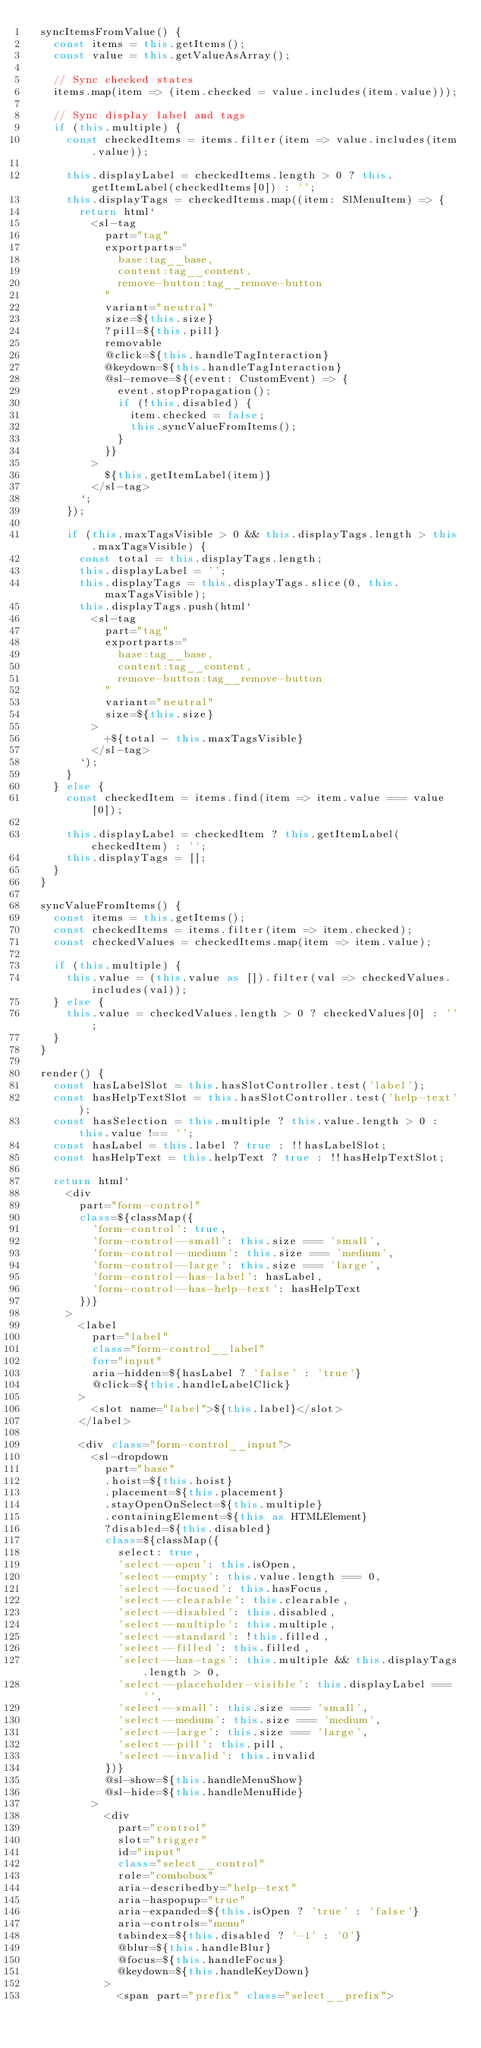<code> <loc_0><loc_0><loc_500><loc_500><_TypeScript_>  syncItemsFromValue() {
    const items = this.getItems();
    const value = this.getValueAsArray();

    // Sync checked states
    items.map(item => (item.checked = value.includes(item.value)));

    // Sync display label and tags
    if (this.multiple) {
      const checkedItems = items.filter(item => value.includes(item.value));

      this.displayLabel = checkedItems.length > 0 ? this.getItemLabel(checkedItems[0]) : '';
      this.displayTags = checkedItems.map((item: SlMenuItem) => {
        return html`
          <sl-tag
            part="tag"
            exportparts="
              base:tag__base,
              content:tag__content,
              remove-button:tag__remove-button
            "
            variant="neutral"
            size=${this.size}
            ?pill=${this.pill}
            removable
            @click=${this.handleTagInteraction}
            @keydown=${this.handleTagInteraction}
            @sl-remove=${(event: CustomEvent) => {
              event.stopPropagation();
              if (!this.disabled) {
                item.checked = false;
                this.syncValueFromItems();
              }
            }}
          >
            ${this.getItemLabel(item)}
          </sl-tag>
        `;
      });

      if (this.maxTagsVisible > 0 && this.displayTags.length > this.maxTagsVisible) {
        const total = this.displayTags.length;
        this.displayLabel = '';
        this.displayTags = this.displayTags.slice(0, this.maxTagsVisible);
        this.displayTags.push(html`
          <sl-tag
            part="tag"
            exportparts="
              base:tag__base,
              content:tag__content,
              remove-button:tag__remove-button
            "
            variant="neutral"
            size=${this.size}
          >
            +${total - this.maxTagsVisible}
          </sl-tag>
        `);
      }
    } else {
      const checkedItem = items.find(item => item.value === value[0]);

      this.displayLabel = checkedItem ? this.getItemLabel(checkedItem) : '';
      this.displayTags = [];
    }
  }

  syncValueFromItems() {
    const items = this.getItems();
    const checkedItems = items.filter(item => item.checked);
    const checkedValues = checkedItems.map(item => item.value);

    if (this.multiple) {
      this.value = (this.value as []).filter(val => checkedValues.includes(val));
    } else {
      this.value = checkedValues.length > 0 ? checkedValues[0] : '';
    }
  }

  render() {
    const hasLabelSlot = this.hasSlotController.test('label');
    const hasHelpTextSlot = this.hasSlotController.test('help-text');
    const hasSelection = this.multiple ? this.value.length > 0 : this.value !== '';
    const hasLabel = this.label ? true : !!hasLabelSlot;
    const hasHelpText = this.helpText ? true : !!hasHelpTextSlot;

    return html`
      <div
        part="form-control"
        class=${classMap({
          'form-control': true,
          'form-control--small': this.size === 'small',
          'form-control--medium': this.size === 'medium',
          'form-control--large': this.size === 'large',
          'form-control--has-label': hasLabel,
          'form-control--has-help-text': hasHelpText
        })}
      >
        <label
          part="label"
          class="form-control__label"
          for="input"
          aria-hidden=${hasLabel ? 'false' : 'true'}
          @click=${this.handleLabelClick}
        >
          <slot name="label">${this.label}</slot>
        </label>

        <div class="form-control__input">
          <sl-dropdown
            part="base"
            .hoist=${this.hoist}
            .placement=${this.placement}
            .stayOpenOnSelect=${this.multiple}
            .containingElement=${this as HTMLElement}
            ?disabled=${this.disabled}
            class=${classMap({
              select: true,
              'select--open': this.isOpen,
              'select--empty': this.value.length === 0,
              'select--focused': this.hasFocus,
              'select--clearable': this.clearable,
              'select--disabled': this.disabled,
              'select--multiple': this.multiple,
              'select--standard': !this.filled,
              'select--filled': this.filled,
              'select--has-tags': this.multiple && this.displayTags.length > 0,
              'select--placeholder-visible': this.displayLabel === '',
              'select--small': this.size === 'small',
              'select--medium': this.size === 'medium',
              'select--large': this.size === 'large',
              'select--pill': this.pill,
              'select--invalid': this.invalid
            })}
            @sl-show=${this.handleMenuShow}
            @sl-hide=${this.handleMenuHide}
          >
            <div
              part="control"
              slot="trigger"
              id="input"
              class="select__control"
              role="combobox"
              aria-describedby="help-text"
              aria-haspopup="true"
              aria-expanded=${this.isOpen ? 'true' : 'false'}
              aria-controls="menu"
              tabindex=${this.disabled ? '-1' : '0'}
              @blur=${this.handleBlur}
              @focus=${this.handleFocus}
              @keydown=${this.handleKeyDown}
            >
              <span part="prefix" class="select__prefix"></code> 